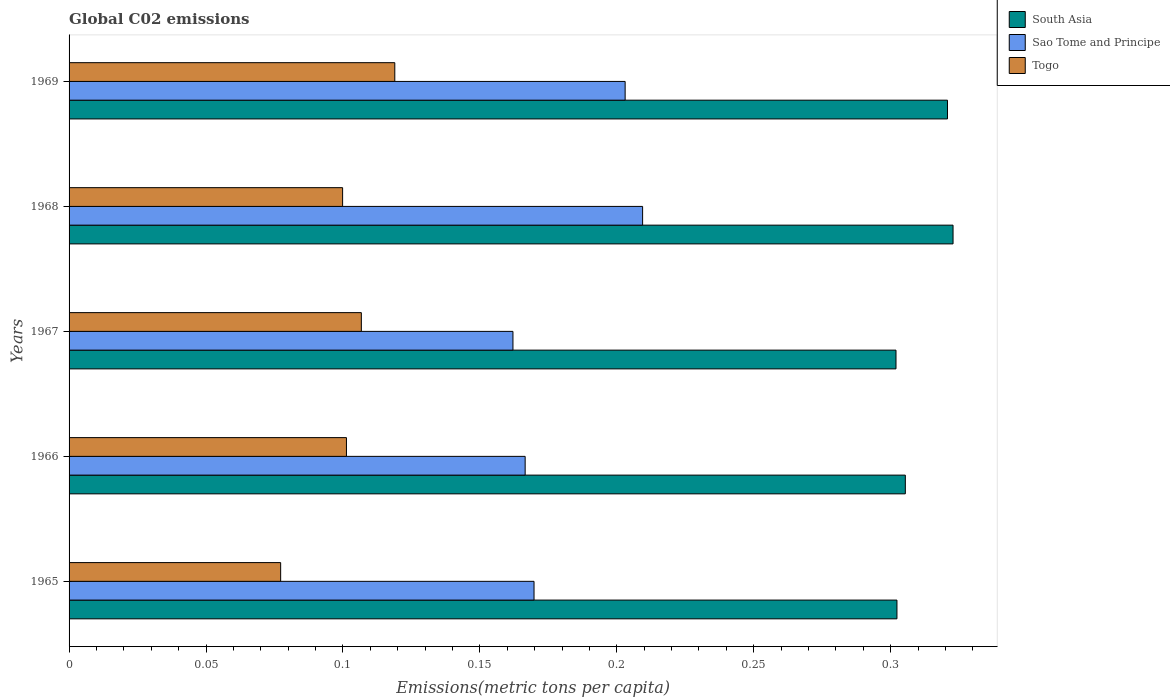How many groups of bars are there?
Provide a succinct answer. 5. Are the number of bars per tick equal to the number of legend labels?
Your answer should be compact. Yes. What is the label of the 5th group of bars from the top?
Your answer should be compact. 1965. What is the amount of CO2 emitted in in Sao Tome and Principe in 1966?
Your answer should be very brief. 0.17. Across all years, what is the maximum amount of CO2 emitted in in Sao Tome and Principe?
Ensure brevity in your answer.  0.21. Across all years, what is the minimum amount of CO2 emitted in in South Asia?
Make the answer very short. 0.3. In which year was the amount of CO2 emitted in in Sao Tome and Principe maximum?
Your answer should be very brief. 1968. In which year was the amount of CO2 emitted in in Sao Tome and Principe minimum?
Provide a succinct answer. 1967. What is the total amount of CO2 emitted in in Togo in the graph?
Your answer should be very brief. 0.5. What is the difference between the amount of CO2 emitted in in Sao Tome and Principe in 1967 and that in 1969?
Make the answer very short. -0.04. What is the difference between the amount of CO2 emitted in in Togo in 1967 and the amount of CO2 emitted in in Sao Tome and Principe in 1969?
Your response must be concise. -0.1. What is the average amount of CO2 emitted in in South Asia per year?
Offer a terse response. 0.31. In the year 1969, what is the difference between the amount of CO2 emitted in in Togo and amount of CO2 emitted in in South Asia?
Provide a short and direct response. -0.2. What is the ratio of the amount of CO2 emitted in in Sao Tome and Principe in 1967 to that in 1968?
Offer a terse response. 0.77. Is the amount of CO2 emitted in in South Asia in 1965 less than that in 1969?
Provide a succinct answer. Yes. What is the difference between the highest and the second highest amount of CO2 emitted in in South Asia?
Offer a terse response. 0. What is the difference between the highest and the lowest amount of CO2 emitted in in Sao Tome and Principe?
Make the answer very short. 0.05. Is the sum of the amount of CO2 emitted in in Sao Tome and Principe in 1967 and 1969 greater than the maximum amount of CO2 emitted in in South Asia across all years?
Ensure brevity in your answer.  Yes. What does the 3rd bar from the top in 1967 represents?
Keep it short and to the point. South Asia. What does the 1st bar from the bottom in 1966 represents?
Give a very brief answer. South Asia. Are the values on the major ticks of X-axis written in scientific E-notation?
Ensure brevity in your answer.  No. Does the graph contain grids?
Make the answer very short. No. How many legend labels are there?
Provide a succinct answer. 3. How are the legend labels stacked?
Provide a succinct answer. Vertical. What is the title of the graph?
Your response must be concise. Global C02 emissions. Does "Swaziland" appear as one of the legend labels in the graph?
Keep it short and to the point. No. What is the label or title of the X-axis?
Offer a terse response. Emissions(metric tons per capita). What is the label or title of the Y-axis?
Keep it short and to the point. Years. What is the Emissions(metric tons per capita) in South Asia in 1965?
Your response must be concise. 0.3. What is the Emissions(metric tons per capita) in Sao Tome and Principe in 1965?
Give a very brief answer. 0.17. What is the Emissions(metric tons per capita) in Togo in 1965?
Ensure brevity in your answer.  0.08. What is the Emissions(metric tons per capita) in South Asia in 1966?
Make the answer very short. 0.31. What is the Emissions(metric tons per capita) in Sao Tome and Principe in 1966?
Make the answer very short. 0.17. What is the Emissions(metric tons per capita) in Togo in 1966?
Ensure brevity in your answer.  0.1. What is the Emissions(metric tons per capita) in South Asia in 1967?
Offer a terse response. 0.3. What is the Emissions(metric tons per capita) in Sao Tome and Principe in 1967?
Offer a terse response. 0.16. What is the Emissions(metric tons per capita) in Togo in 1967?
Your answer should be compact. 0.11. What is the Emissions(metric tons per capita) of South Asia in 1968?
Offer a terse response. 0.32. What is the Emissions(metric tons per capita) of Sao Tome and Principe in 1968?
Your response must be concise. 0.21. What is the Emissions(metric tons per capita) in Togo in 1968?
Your answer should be very brief. 0.1. What is the Emissions(metric tons per capita) in South Asia in 1969?
Keep it short and to the point. 0.32. What is the Emissions(metric tons per capita) in Sao Tome and Principe in 1969?
Provide a short and direct response. 0.2. What is the Emissions(metric tons per capita) in Togo in 1969?
Your response must be concise. 0.12. Across all years, what is the maximum Emissions(metric tons per capita) of South Asia?
Offer a very short reply. 0.32. Across all years, what is the maximum Emissions(metric tons per capita) of Sao Tome and Principe?
Provide a short and direct response. 0.21. Across all years, what is the maximum Emissions(metric tons per capita) of Togo?
Provide a succinct answer. 0.12. Across all years, what is the minimum Emissions(metric tons per capita) in South Asia?
Provide a short and direct response. 0.3. Across all years, what is the minimum Emissions(metric tons per capita) in Sao Tome and Principe?
Your answer should be compact. 0.16. Across all years, what is the minimum Emissions(metric tons per capita) in Togo?
Provide a short and direct response. 0.08. What is the total Emissions(metric tons per capita) in South Asia in the graph?
Make the answer very short. 1.55. What is the total Emissions(metric tons per capita) in Sao Tome and Principe in the graph?
Offer a terse response. 0.91. What is the total Emissions(metric tons per capita) in Togo in the graph?
Make the answer very short. 0.5. What is the difference between the Emissions(metric tons per capita) in South Asia in 1965 and that in 1966?
Your answer should be compact. -0. What is the difference between the Emissions(metric tons per capita) of Sao Tome and Principe in 1965 and that in 1966?
Keep it short and to the point. 0. What is the difference between the Emissions(metric tons per capita) of Togo in 1965 and that in 1966?
Make the answer very short. -0.02. What is the difference between the Emissions(metric tons per capita) in Sao Tome and Principe in 1965 and that in 1967?
Offer a very short reply. 0.01. What is the difference between the Emissions(metric tons per capita) of Togo in 1965 and that in 1967?
Keep it short and to the point. -0.03. What is the difference between the Emissions(metric tons per capita) in South Asia in 1965 and that in 1968?
Offer a terse response. -0.02. What is the difference between the Emissions(metric tons per capita) in Sao Tome and Principe in 1965 and that in 1968?
Make the answer very short. -0.04. What is the difference between the Emissions(metric tons per capita) in Togo in 1965 and that in 1968?
Give a very brief answer. -0.02. What is the difference between the Emissions(metric tons per capita) of South Asia in 1965 and that in 1969?
Ensure brevity in your answer.  -0.02. What is the difference between the Emissions(metric tons per capita) of Sao Tome and Principe in 1965 and that in 1969?
Make the answer very short. -0.03. What is the difference between the Emissions(metric tons per capita) in Togo in 1965 and that in 1969?
Provide a short and direct response. -0.04. What is the difference between the Emissions(metric tons per capita) of South Asia in 1966 and that in 1967?
Your response must be concise. 0. What is the difference between the Emissions(metric tons per capita) of Sao Tome and Principe in 1966 and that in 1967?
Give a very brief answer. 0. What is the difference between the Emissions(metric tons per capita) of Togo in 1966 and that in 1967?
Give a very brief answer. -0.01. What is the difference between the Emissions(metric tons per capita) in South Asia in 1966 and that in 1968?
Your answer should be very brief. -0.02. What is the difference between the Emissions(metric tons per capita) in Sao Tome and Principe in 1966 and that in 1968?
Your answer should be very brief. -0.04. What is the difference between the Emissions(metric tons per capita) of Togo in 1966 and that in 1968?
Offer a terse response. 0. What is the difference between the Emissions(metric tons per capita) of South Asia in 1966 and that in 1969?
Give a very brief answer. -0.02. What is the difference between the Emissions(metric tons per capita) of Sao Tome and Principe in 1966 and that in 1969?
Keep it short and to the point. -0.04. What is the difference between the Emissions(metric tons per capita) in Togo in 1966 and that in 1969?
Your response must be concise. -0.02. What is the difference between the Emissions(metric tons per capita) of South Asia in 1967 and that in 1968?
Make the answer very short. -0.02. What is the difference between the Emissions(metric tons per capita) in Sao Tome and Principe in 1967 and that in 1968?
Your response must be concise. -0.05. What is the difference between the Emissions(metric tons per capita) of Togo in 1967 and that in 1968?
Make the answer very short. 0.01. What is the difference between the Emissions(metric tons per capita) of South Asia in 1967 and that in 1969?
Ensure brevity in your answer.  -0.02. What is the difference between the Emissions(metric tons per capita) of Sao Tome and Principe in 1967 and that in 1969?
Your answer should be compact. -0.04. What is the difference between the Emissions(metric tons per capita) of Togo in 1967 and that in 1969?
Provide a short and direct response. -0.01. What is the difference between the Emissions(metric tons per capita) in South Asia in 1968 and that in 1969?
Offer a very short reply. 0. What is the difference between the Emissions(metric tons per capita) of Sao Tome and Principe in 1968 and that in 1969?
Make the answer very short. 0.01. What is the difference between the Emissions(metric tons per capita) of Togo in 1968 and that in 1969?
Ensure brevity in your answer.  -0.02. What is the difference between the Emissions(metric tons per capita) in South Asia in 1965 and the Emissions(metric tons per capita) in Sao Tome and Principe in 1966?
Provide a short and direct response. 0.14. What is the difference between the Emissions(metric tons per capita) of South Asia in 1965 and the Emissions(metric tons per capita) of Togo in 1966?
Offer a very short reply. 0.2. What is the difference between the Emissions(metric tons per capita) of Sao Tome and Principe in 1965 and the Emissions(metric tons per capita) of Togo in 1966?
Your answer should be compact. 0.07. What is the difference between the Emissions(metric tons per capita) of South Asia in 1965 and the Emissions(metric tons per capita) of Sao Tome and Principe in 1967?
Your answer should be very brief. 0.14. What is the difference between the Emissions(metric tons per capita) in South Asia in 1965 and the Emissions(metric tons per capita) in Togo in 1967?
Your answer should be very brief. 0.2. What is the difference between the Emissions(metric tons per capita) in Sao Tome and Principe in 1965 and the Emissions(metric tons per capita) in Togo in 1967?
Make the answer very short. 0.06. What is the difference between the Emissions(metric tons per capita) of South Asia in 1965 and the Emissions(metric tons per capita) of Sao Tome and Principe in 1968?
Provide a short and direct response. 0.09. What is the difference between the Emissions(metric tons per capita) of South Asia in 1965 and the Emissions(metric tons per capita) of Togo in 1968?
Offer a very short reply. 0.2. What is the difference between the Emissions(metric tons per capita) of Sao Tome and Principe in 1965 and the Emissions(metric tons per capita) of Togo in 1968?
Keep it short and to the point. 0.07. What is the difference between the Emissions(metric tons per capita) of South Asia in 1965 and the Emissions(metric tons per capita) of Sao Tome and Principe in 1969?
Offer a very short reply. 0.1. What is the difference between the Emissions(metric tons per capita) of South Asia in 1965 and the Emissions(metric tons per capita) of Togo in 1969?
Your answer should be very brief. 0.18. What is the difference between the Emissions(metric tons per capita) in Sao Tome and Principe in 1965 and the Emissions(metric tons per capita) in Togo in 1969?
Your response must be concise. 0.05. What is the difference between the Emissions(metric tons per capita) in South Asia in 1966 and the Emissions(metric tons per capita) in Sao Tome and Principe in 1967?
Ensure brevity in your answer.  0.14. What is the difference between the Emissions(metric tons per capita) in South Asia in 1966 and the Emissions(metric tons per capita) in Togo in 1967?
Your response must be concise. 0.2. What is the difference between the Emissions(metric tons per capita) of Sao Tome and Principe in 1966 and the Emissions(metric tons per capita) of Togo in 1967?
Your answer should be compact. 0.06. What is the difference between the Emissions(metric tons per capita) in South Asia in 1966 and the Emissions(metric tons per capita) in Sao Tome and Principe in 1968?
Provide a short and direct response. 0.1. What is the difference between the Emissions(metric tons per capita) in South Asia in 1966 and the Emissions(metric tons per capita) in Togo in 1968?
Provide a short and direct response. 0.21. What is the difference between the Emissions(metric tons per capita) in Sao Tome and Principe in 1966 and the Emissions(metric tons per capita) in Togo in 1968?
Keep it short and to the point. 0.07. What is the difference between the Emissions(metric tons per capita) of South Asia in 1966 and the Emissions(metric tons per capita) of Sao Tome and Principe in 1969?
Offer a very short reply. 0.1. What is the difference between the Emissions(metric tons per capita) of South Asia in 1966 and the Emissions(metric tons per capita) of Togo in 1969?
Your answer should be compact. 0.19. What is the difference between the Emissions(metric tons per capita) of Sao Tome and Principe in 1966 and the Emissions(metric tons per capita) of Togo in 1969?
Your response must be concise. 0.05. What is the difference between the Emissions(metric tons per capita) in South Asia in 1967 and the Emissions(metric tons per capita) in Sao Tome and Principe in 1968?
Provide a short and direct response. 0.09. What is the difference between the Emissions(metric tons per capita) of South Asia in 1967 and the Emissions(metric tons per capita) of Togo in 1968?
Provide a short and direct response. 0.2. What is the difference between the Emissions(metric tons per capita) in Sao Tome and Principe in 1967 and the Emissions(metric tons per capita) in Togo in 1968?
Make the answer very short. 0.06. What is the difference between the Emissions(metric tons per capita) in South Asia in 1967 and the Emissions(metric tons per capita) in Sao Tome and Principe in 1969?
Offer a very short reply. 0.1. What is the difference between the Emissions(metric tons per capita) of South Asia in 1967 and the Emissions(metric tons per capita) of Togo in 1969?
Ensure brevity in your answer.  0.18. What is the difference between the Emissions(metric tons per capita) of Sao Tome and Principe in 1967 and the Emissions(metric tons per capita) of Togo in 1969?
Offer a very short reply. 0.04. What is the difference between the Emissions(metric tons per capita) of South Asia in 1968 and the Emissions(metric tons per capita) of Sao Tome and Principe in 1969?
Your answer should be compact. 0.12. What is the difference between the Emissions(metric tons per capita) of South Asia in 1968 and the Emissions(metric tons per capita) of Togo in 1969?
Keep it short and to the point. 0.2. What is the difference between the Emissions(metric tons per capita) in Sao Tome and Principe in 1968 and the Emissions(metric tons per capita) in Togo in 1969?
Your answer should be compact. 0.09. What is the average Emissions(metric tons per capita) in South Asia per year?
Your response must be concise. 0.31. What is the average Emissions(metric tons per capita) in Sao Tome and Principe per year?
Your answer should be very brief. 0.18. What is the average Emissions(metric tons per capita) in Togo per year?
Offer a very short reply. 0.1. In the year 1965, what is the difference between the Emissions(metric tons per capita) of South Asia and Emissions(metric tons per capita) of Sao Tome and Principe?
Your answer should be very brief. 0.13. In the year 1965, what is the difference between the Emissions(metric tons per capita) in South Asia and Emissions(metric tons per capita) in Togo?
Ensure brevity in your answer.  0.23. In the year 1965, what is the difference between the Emissions(metric tons per capita) in Sao Tome and Principe and Emissions(metric tons per capita) in Togo?
Offer a terse response. 0.09. In the year 1966, what is the difference between the Emissions(metric tons per capita) in South Asia and Emissions(metric tons per capita) in Sao Tome and Principe?
Your answer should be very brief. 0.14. In the year 1966, what is the difference between the Emissions(metric tons per capita) in South Asia and Emissions(metric tons per capita) in Togo?
Keep it short and to the point. 0.2. In the year 1966, what is the difference between the Emissions(metric tons per capita) in Sao Tome and Principe and Emissions(metric tons per capita) in Togo?
Offer a terse response. 0.07. In the year 1967, what is the difference between the Emissions(metric tons per capita) of South Asia and Emissions(metric tons per capita) of Sao Tome and Principe?
Give a very brief answer. 0.14. In the year 1967, what is the difference between the Emissions(metric tons per capita) of South Asia and Emissions(metric tons per capita) of Togo?
Provide a short and direct response. 0.2. In the year 1967, what is the difference between the Emissions(metric tons per capita) of Sao Tome and Principe and Emissions(metric tons per capita) of Togo?
Offer a terse response. 0.06. In the year 1968, what is the difference between the Emissions(metric tons per capita) of South Asia and Emissions(metric tons per capita) of Sao Tome and Principe?
Offer a very short reply. 0.11. In the year 1968, what is the difference between the Emissions(metric tons per capita) in South Asia and Emissions(metric tons per capita) in Togo?
Make the answer very short. 0.22. In the year 1968, what is the difference between the Emissions(metric tons per capita) of Sao Tome and Principe and Emissions(metric tons per capita) of Togo?
Ensure brevity in your answer.  0.11. In the year 1969, what is the difference between the Emissions(metric tons per capita) of South Asia and Emissions(metric tons per capita) of Sao Tome and Principe?
Your answer should be very brief. 0.12. In the year 1969, what is the difference between the Emissions(metric tons per capita) in South Asia and Emissions(metric tons per capita) in Togo?
Your answer should be compact. 0.2. In the year 1969, what is the difference between the Emissions(metric tons per capita) in Sao Tome and Principe and Emissions(metric tons per capita) in Togo?
Offer a very short reply. 0.08. What is the ratio of the Emissions(metric tons per capita) of Sao Tome and Principe in 1965 to that in 1966?
Keep it short and to the point. 1.02. What is the ratio of the Emissions(metric tons per capita) of Togo in 1965 to that in 1966?
Ensure brevity in your answer.  0.76. What is the ratio of the Emissions(metric tons per capita) of Sao Tome and Principe in 1965 to that in 1967?
Your answer should be compact. 1.05. What is the ratio of the Emissions(metric tons per capita) of Togo in 1965 to that in 1967?
Provide a short and direct response. 0.72. What is the ratio of the Emissions(metric tons per capita) in South Asia in 1965 to that in 1968?
Offer a terse response. 0.94. What is the ratio of the Emissions(metric tons per capita) in Sao Tome and Principe in 1965 to that in 1968?
Your response must be concise. 0.81. What is the ratio of the Emissions(metric tons per capita) of Togo in 1965 to that in 1968?
Your answer should be very brief. 0.77. What is the ratio of the Emissions(metric tons per capita) in South Asia in 1965 to that in 1969?
Your answer should be very brief. 0.94. What is the ratio of the Emissions(metric tons per capita) of Sao Tome and Principe in 1965 to that in 1969?
Give a very brief answer. 0.84. What is the ratio of the Emissions(metric tons per capita) of Togo in 1965 to that in 1969?
Offer a terse response. 0.65. What is the ratio of the Emissions(metric tons per capita) of South Asia in 1966 to that in 1967?
Your answer should be compact. 1.01. What is the ratio of the Emissions(metric tons per capita) in Sao Tome and Principe in 1966 to that in 1967?
Give a very brief answer. 1.03. What is the ratio of the Emissions(metric tons per capita) in Togo in 1966 to that in 1967?
Keep it short and to the point. 0.95. What is the ratio of the Emissions(metric tons per capita) in South Asia in 1966 to that in 1968?
Your answer should be compact. 0.95. What is the ratio of the Emissions(metric tons per capita) in Sao Tome and Principe in 1966 to that in 1968?
Make the answer very short. 0.8. What is the ratio of the Emissions(metric tons per capita) of South Asia in 1966 to that in 1969?
Your answer should be very brief. 0.95. What is the ratio of the Emissions(metric tons per capita) in Sao Tome and Principe in 1966 to that in 1969?
Provide a short and direct response. 0.82. What is the ratio of the Emissions(metric tons per capita) of Togo in 1966 to that in 1969?
Offer a terse response. 0.85. What is the ratio of the Emissions(metric tons per capita) in South Asia in 1967 to that in 1968?
Offer a very short reply. 0.94. What is the ratio of the Emissions(metric tons per capita) of Sao Tome and Principe in 1967 to that in 1968?
Offer a very short reply. 0.77. What is the ratio of the Emissions(metric tons per capita) of Togo in 1967 to that in 1968?
Your response must be concise. 1.07. What is the ratio of the Emissions(metric tons per capita) of South Asia in 1967 to that in 1969?
Offer a terse response. 0.94. What is the ratio of the Emissions(metric tons per capita) of Sao Tome and Principe in 1967 to that in 1969?
Keep it short and to the point. 0.8. What is the ratio of the Emissions(metric tons per capita) of Togo in 1967 to that in 1969?
Offer a very short reply. 0.9. What is the ratio of the Emissions(metric tons per capita) in Sao Tome and Principe in 1968 to that in 1969?
Keep it short and to the point. 1.03. What is the ratio of the Emissions(metric tons per capita) of Togo in 1968 to that in 1969?
Offer a terse response. 0.84. What is the difference between the highest and the second highest Emissions(metric tons per capita) in South Asia?
Provide a short and direct response. 0. What is the difference between the highest and the second highest Emissions(metric tons per capita) of Sao Tome and Principe?
Provide a succinct answer. 0.01. What is the difference between the highest and the second highest Emissions(metric tons per capita) of Togo?
Offer a very short reply. 0.01. What is the difference between the highest and the lowest Emissions(metric tons per capita) in South Asia?
Your answer should be very brief. 0.02. What is the difference between the highest and the lowest Emissions(metric tons per capita) of Sao Tome and Principe?
Provide a short and direct response. 0.05. What is the difference between the highest and the lowest Emissions(metric tons per capita) in Togo?
Your answer should be very brief. 0.04. 